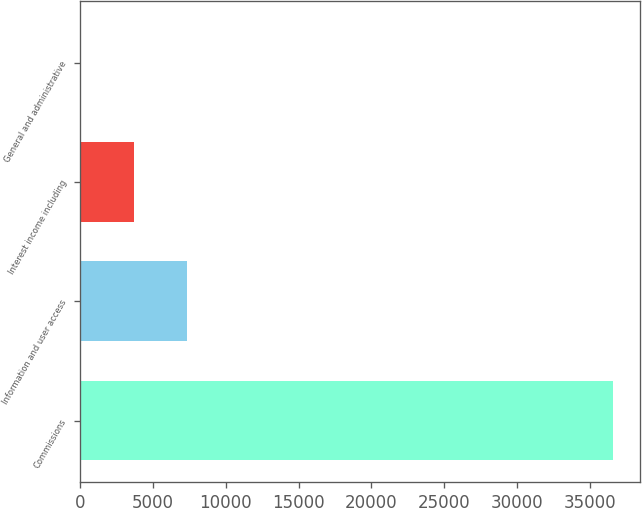<chart> <loc_0><loc_0><loc_500><loc_500><bar_chart><fcel>Commissions<fcel>Information and user access<fcel>Interest income including<fcel>General and administrative<nl><fcel>36588<fcel>7364.8<fcel>3711.9<fcel>59<nl></chart> 